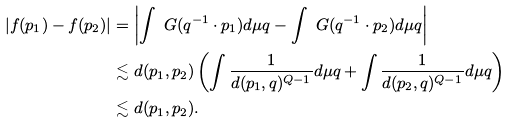Convert formula to latex. <formula><loc_0><loc_0><loc_500><loc_500>| f ( p _ { 1 } ) - f ( p _ { 2 } ) | & = \left | \int \ G ( q ^ { - 1 } \cdot p _ { 1 } ) d \mu q - \int \ G ( q ^ { - 1 } \cdot p _ { 2 } ) d \mu q \right | \\ & \lesssim d ( p _ { 1 } , p _ { 2 } ) \left ( \int \frac { 1 } { d ( p _ { 1 } , q ) ^ { Q - 1 } } d \mu q + \int \frac { 1 } { d ( p _ { 2 } , q ) ^ { Q - 1 } } d \mu q \right ) \\ & \lesssim d ( p _ { 1 } , p _ { 2 } ) .</formula> 